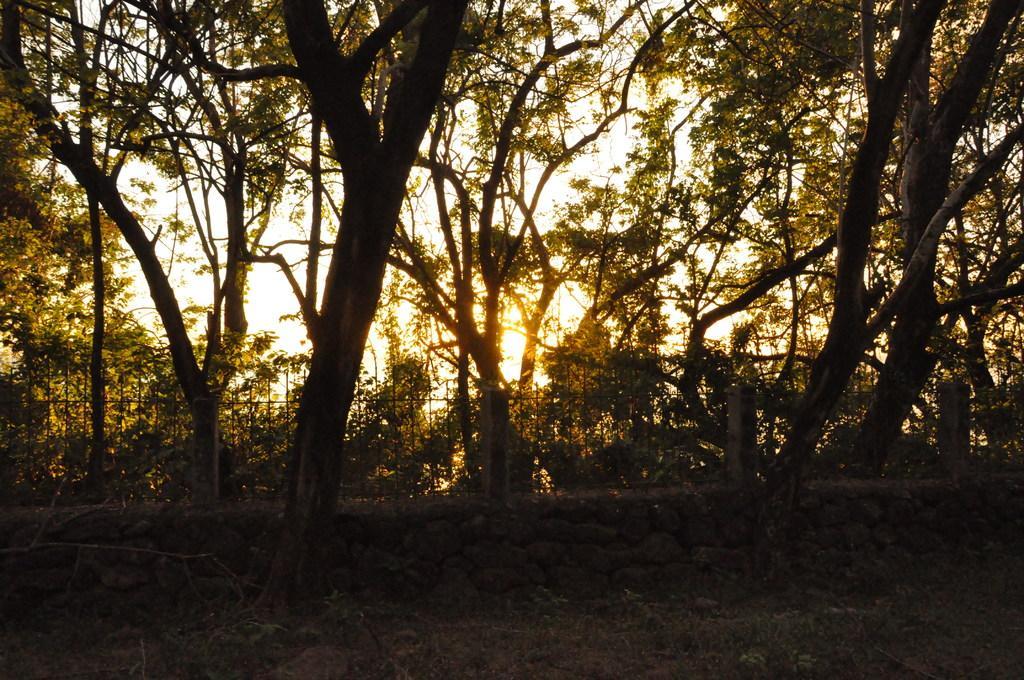How would you summarize this image in a sentence or two? In this image we can see trees. There is a fencing. At the bottom of the image there are plants, grass. 